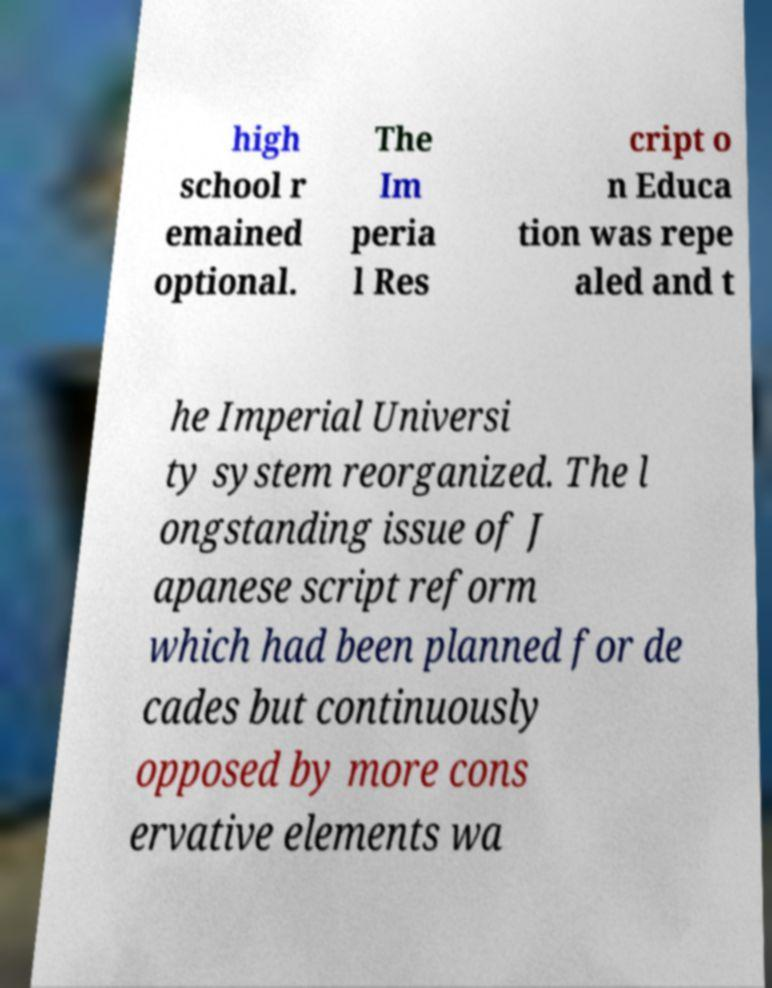Could you assist in decoding the text presented in this image and type it out clearly? high school r emained optional. The Im peria l Res cript o n Educa tion was repe aled and t he Imperial Universi ty system reorganized. The l ongstanding issue of J apanese script reform which had been planned for de cades but continuously opposed by more cons ervative elements wa 